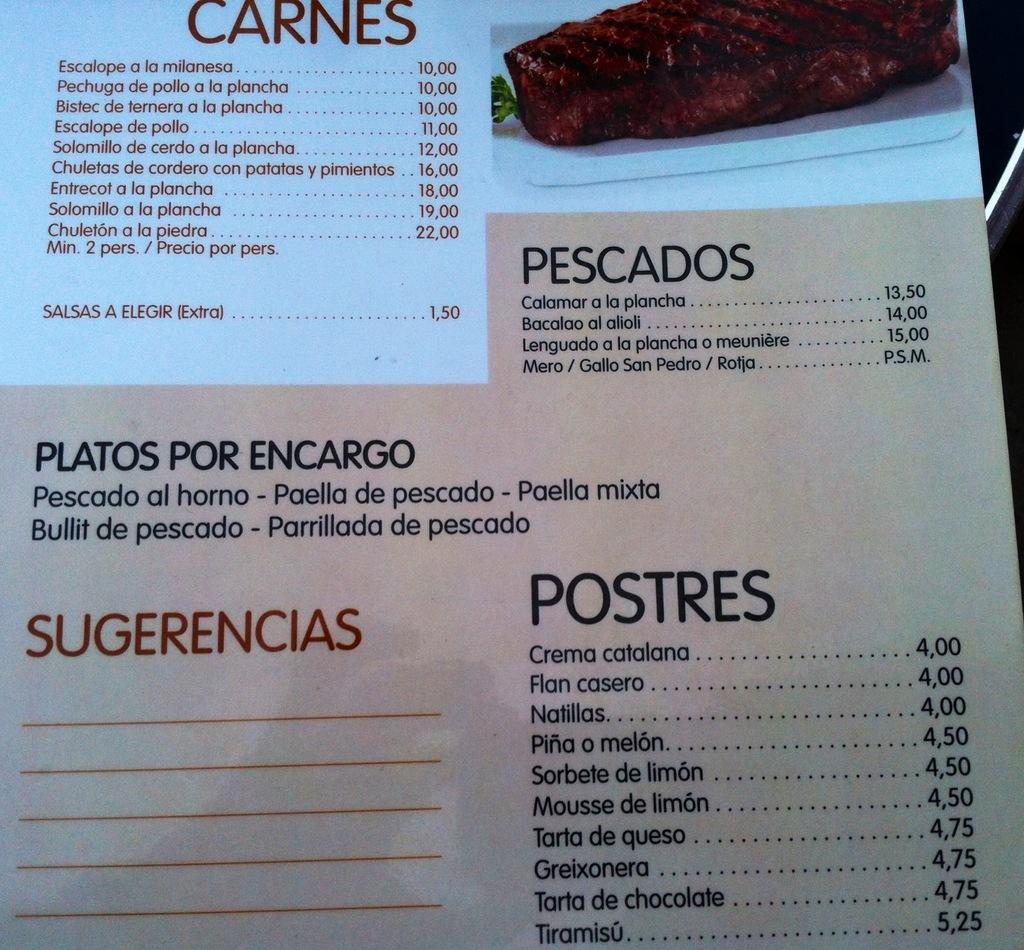What is present in the image that might be used for making food choices? There is a menu in the image. Can you describe the menu in the image? There is writing on the menu. What type of lettuce can be seen growing downtown in the image? There is no lettuce or downtown location present in the image; it only features a menu with writing on it. 